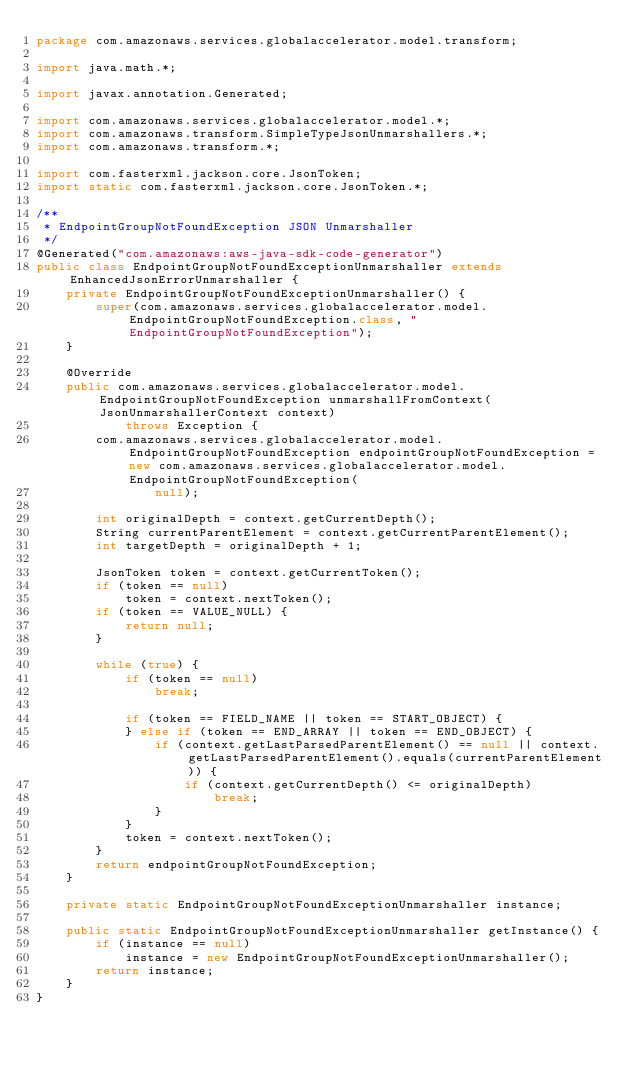Convert code to text. <code><loc_0><loc_0><loc_500><loc_500><_Java_>package com.amazonaws.services.globalaccelerator.model.transform;

import java.math.*;

import javax.annotation.Generated;

import com.amazonaws.services.globalaccelerator.model.*;
import com.amazonaws.transform.SimpleTypeJsonUnmarshallers.*;
import com.amazonaws.transform.*;

import com.fasterxml.jackson.core.JsonToken;
import static com.fasterxml.jackson.core.JsonToken.*;

/**
 * EndpointGroupNotFoundException JSON Unmarshaller
 */
@Generated("com.amazonaws:aws-java-sdk-code-generator")
public class EndpointGroupNotFoundExceptionUnmarshaller extends EnhancedJsonErrorUnmarshaller {
    private EndpointGroupNotFoundExceptionUnmarshaller() {
        super(com.amazonaws.services.globalaccelerator.model.EndpointGroupNotFoundException.class, "EndpointGroupNotFoundException");
    }

    @Override
    public com.amazonaws.services.globalaccelerator.model.EndpointGroupNotFoundException unmarshallFromContext(JsonUnmarshallerContext context)
            throws Exception {
        com.amazonaws.services.globalaccelerator.model.EndpointGroupNotFoundException endpointGroupNotFoundException = new com.amazonaws.services.globalaccelerator.model.EndpointGroupNotFoundException(
                null);

        int originalDepth = context.getCurrentDepth();
        String currentParentElement = context.getCurrentParentElement();
        int targetDepth = originalDepth + 1;

        JsonToken token = context.getCurrentToken();
        if (token == null)
            token = context.nextToken();
        if (token == VALUE_NULL) {
            return null;
        }

        while (true) {
            if (token == null)
                break;

            if (token == FIELD_NAME || token == START_OBJECT) {
            } else if (token == END_ARRAY || token == END_OBJECT) {
                if (context.getLastParsedParentElement() == null || context.getLastParsedParentElement().equals(currentParentElement)) {
                    if (context.getCurrentDepth() <= originalDepth)
                        break;
                }
            }
            token = context.nextToken();
        }
        return endpointGroupNotFoundException;
    }

    private static EndpointGroupNotFoundExceptionUnmarshaller instance;

    public static EndpointGroupNotFoundExceptionUnmarshaller getInstance() {
        if (instance == null)
            instance = new EndpointGroupNotFoundExceptionUnmarshaller();
        return instance;
    }
}
</code> 